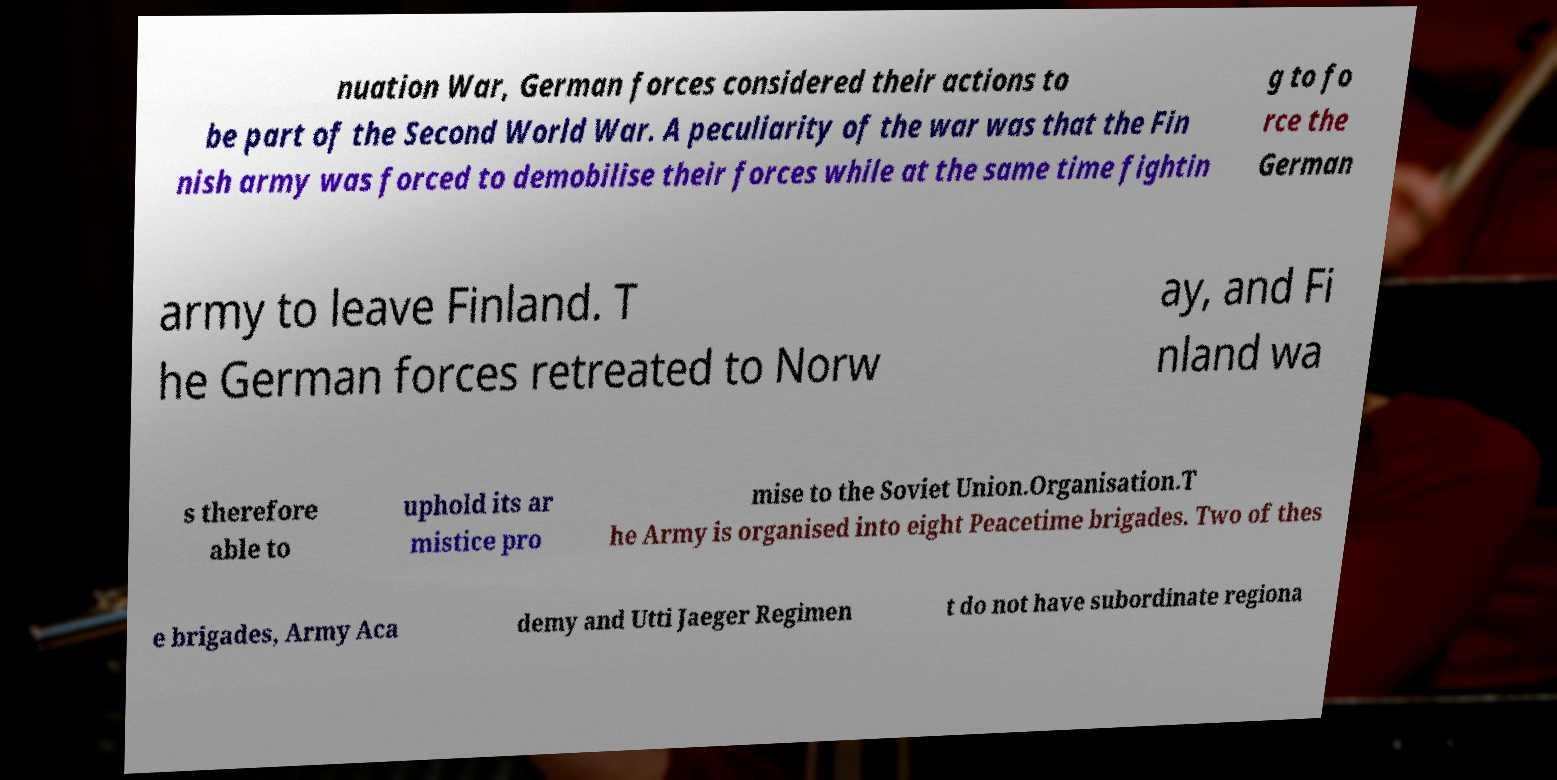For documentation purposes, I need the text within this image transcribed. Could you provide that? nuation War, German forces considered their actions to be part of the Second World War. A peculiarity of the war was that the Fin nish army was forced to demobilise their forces while at the same time fightin g to fo rce the German army to leave Finland. T he German forces retreated to Norw ay, and Fi nland wa s therefore able to uphold its ar mistice pro mise to the Soviet Union.Organisation.T he Army is organised into eight Peacetime brigades. Two of thes e brigades, Army Aca demy and Utti Jaeger Regimen t do not have subordinate regiona 